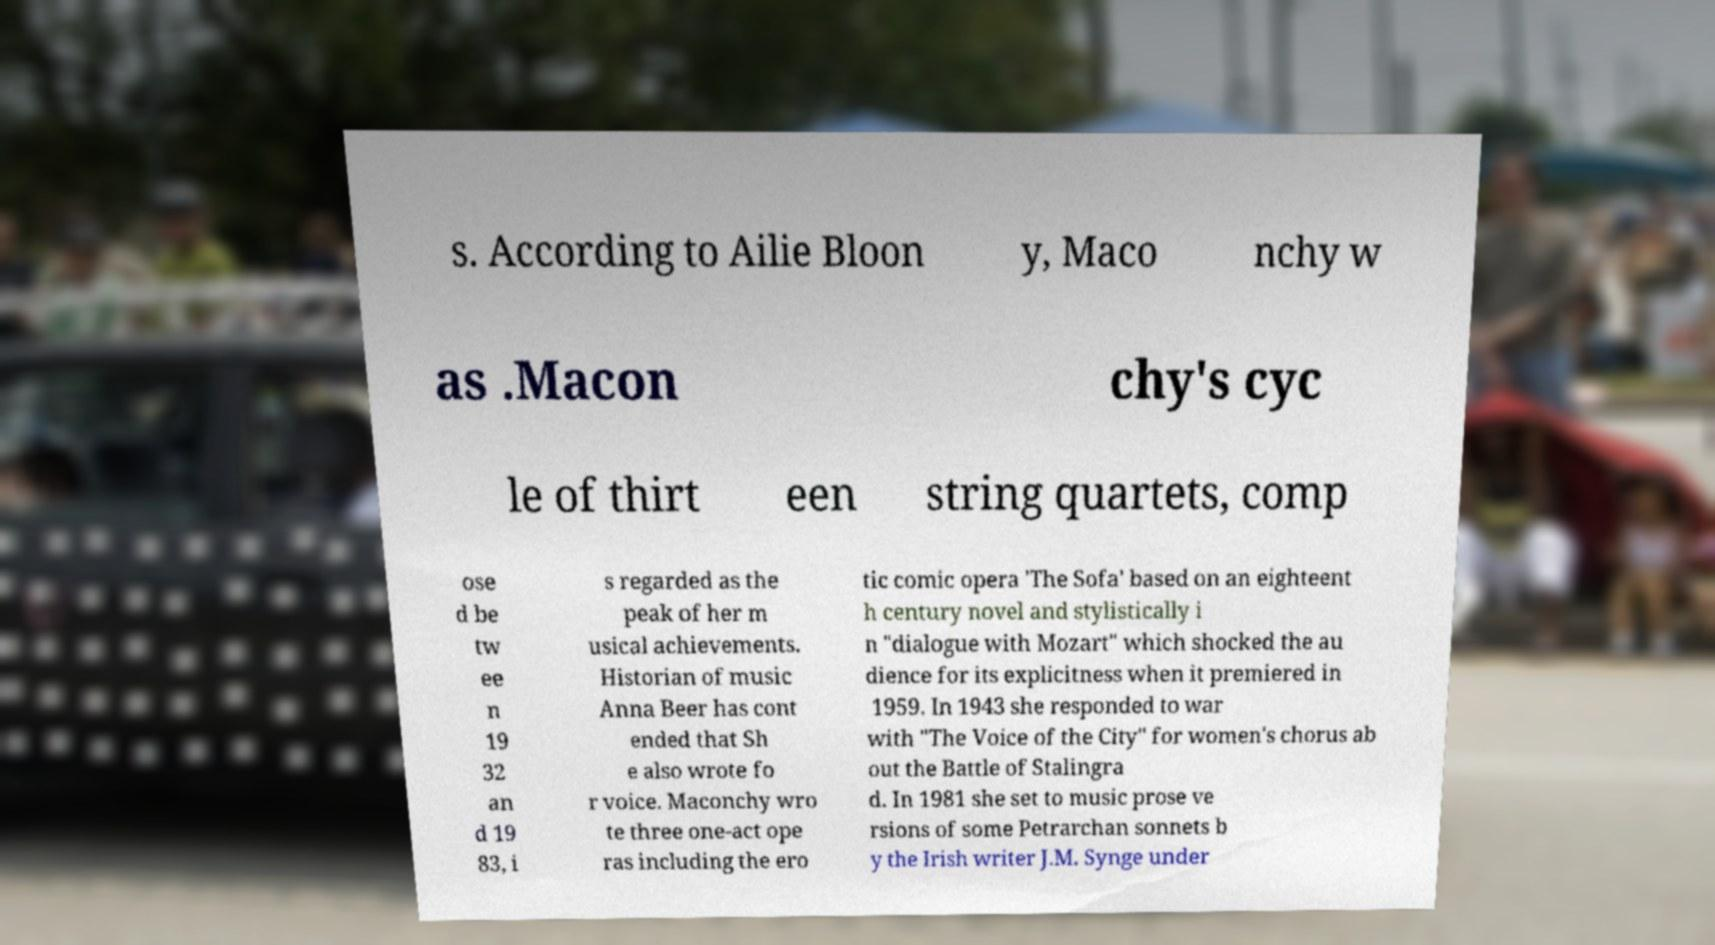Can you accurately transcribe the text from the provided image for me? s. According to Ailie Bloon y, Maco nchy w as .Macon chy's cyc le of thirt een string quartets, comp ose d be tw ee n 19 32 an d 19 83, i s regarded as the peak of her m usical achievements. Historian of music Anna Beer has cont ended that Sh e also wrote fo r voice. Maconchy wro te three one-act ope ras including the ero tic comic opera 'The Sofa' based on an eighteent h century novel and stylistically i n "dialogue with Mozart" which shocked the au dience for its explicitness when it premiered in 1959. In 1943 she responded to war with "The Voice of the City" for women's chorus ab out the Battle of Stalingra d. In 1981 she set to music prose ve rsions of some Petrarchan sonnets b y the Irish writer J.M. Synge under 